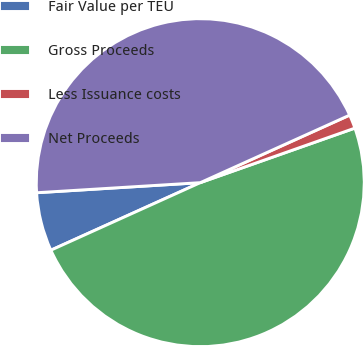Convert chart to OTSL. <chart><loc_0><loc_0><loc_500><loc_500><pie_chart><fcel>Fair Value per TEU<fcel>Gross Proceeds<fcel>Less Issuance costs<fcel>Net Proceeds<nl><fcel>5.78%<fcel>48.64%<fcel>1.36%<fcel>44.22%<nl></chart> 